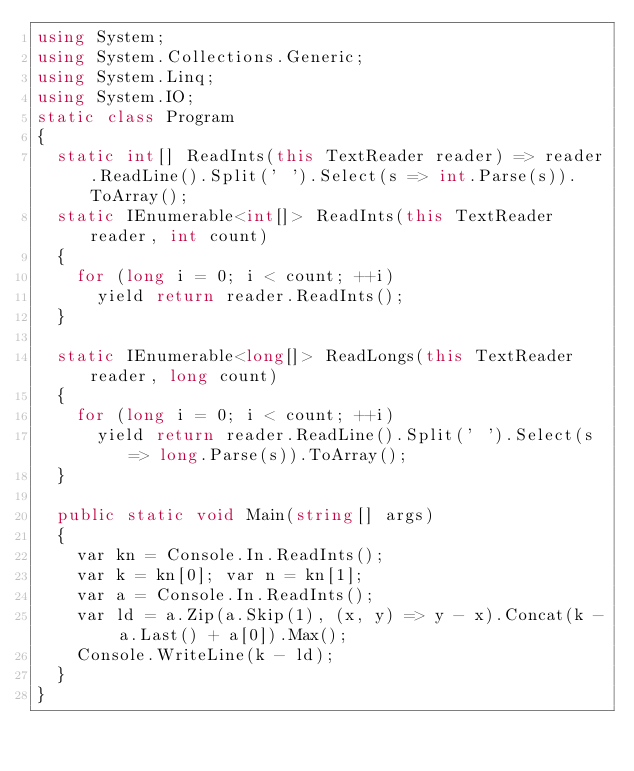<code> <loc_0><loc_0><loc_500><loc_500><_C#_>using System;
using System.Collections.Generic;
using System.Linq;
using System.IO;
static class Program
{
	static int[] ReadInts(this TextReader reader) => reader.ReadLine().Split(' ').Select(s => int.Parse(s)).ToArray();
	static IEnumerable<int[]> ReadInts(this TextReader reader, int count)
	{
		for (long i = 0; i < count; ++i)
			yield return reader.ReadInts();
	}

	static IEnumerable<long[]> ReadLongs(this TextReader reader, long count)
	{
		for (long i = 0; i < count; ++i)
			yield return reader.ReadLine().Split(' ').Select(s => long.Parse(s)).ToArray();
	}
	
	public static void Main(string[] args)
	{
		var kn = Console.In.ReadInts();
		var k = kn[0]; var n = kn[1];
		var a = Console.In.ReadInts();
		var ld = a.Zip(a.Skip(1), (x, y) => y - x).Concat(k - a.Last() + a[0]).Max();
		Console.WriteLine(k - ld);
	}
}</code> 